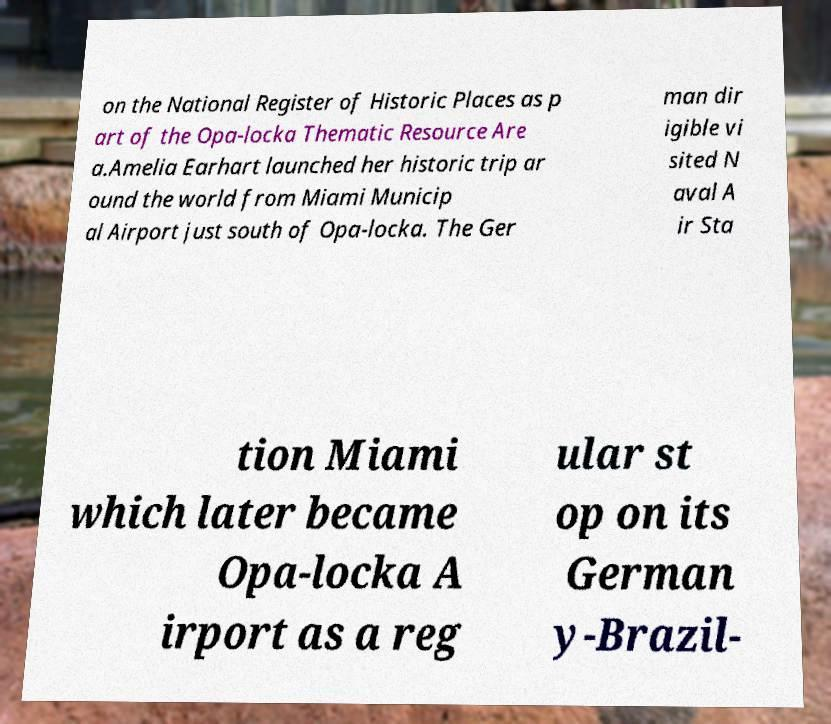Please read and relay the text visible in this image. What does it say? on the National Register of Historic Places as p art of the Opa-locka Thematic Resource Are a.Amelia Earhart launched her historic trip ar ound the world from Miami Municip al Airport just south of Opa-locka. The Ger man dir igible vi sited N aval A ir Sta tion Miami which later became Opa-locka A irport as a reg ular st op on its German y-Brazil- 